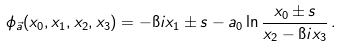Convert formula to latex. <formula><loc_0><loc_0><loc_500><loc_500>\phi _ { \vec { a } } ( x _ { 0 } , x _ { 1 } , x _ { 2 } , x _ { 3 } ) = - \i i x _ { 1 } \pm s - a _ { 0 } \ln \frac { x _ { 0 } \pm s } { x _ { 2 } - \i i x _ { 3 } } \, .</formula> 